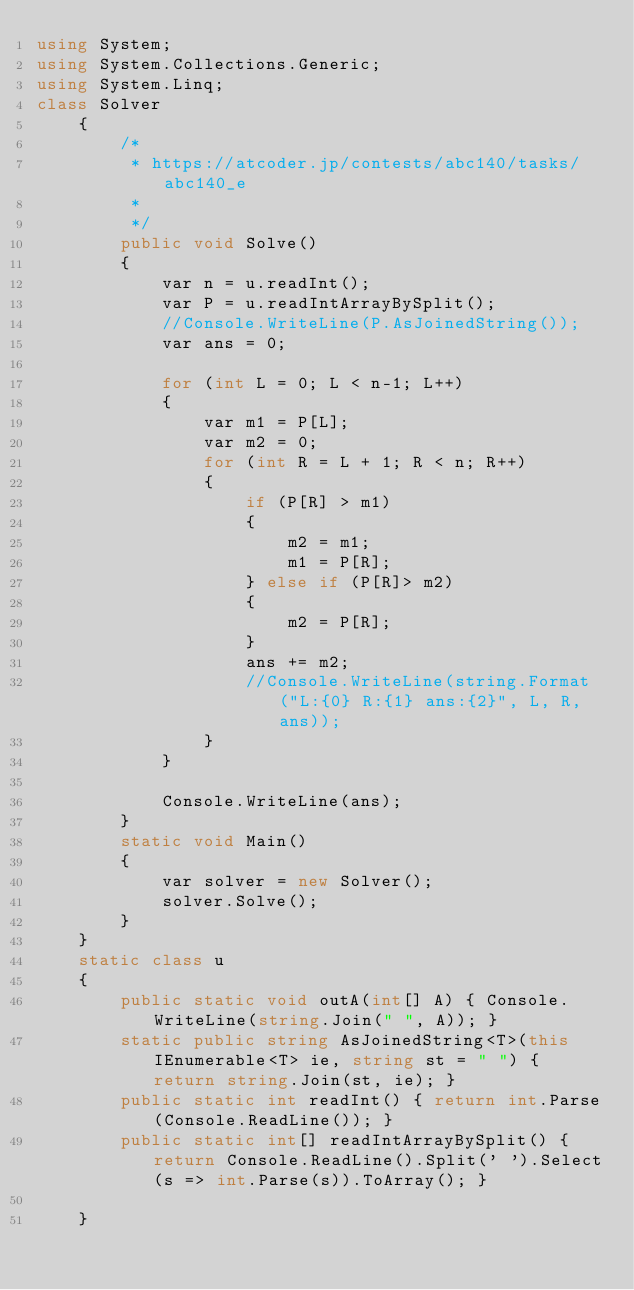Convert code to text. <code><loc_0><loc_0><loc_500><loc_500><_C#_>using System;
using System.Collections.Generic;
using System.Linq;
class Solver
    {
        /*
         * https://atcoder.jp/contests/abc140/tasks/abc140_e
         * 
         */
        public void Solve()
        {
            var n = u.readInt();
            var P = u.readIntArrayBySplit();
            //Console.WriteLine(P.AsJoinedString());
            var ans = 0;

            for (int L = 0; L < n-1; L++)
            {
                var m1 = P[L];
                var m2 = 0;
                for (int R = L + 1; R < n; R++)
                {
                    if (P[R] > m1)
                    {
                        m2 = m1;
                        m1 = P[R];
                    } else if (P[R]> m2)
                    {
                        m2 = P[R];
                    }
                    ans += m2;
                    //Console.WriteLine(string.Format("L:{0} R:{1} ans:{2}", L, R, ans));
                }
            }

            Console.WriteLine(ans);
        }
        static void Main()
        {
            var solver = new Solver();
            solver.Solve();
        }
    }
    static class u
    {
        public static void outA(int[] A) { Console.WriteLine(string.Join(" ", A)); }
        static public string AsJoinedString<T>(this IEnumerable<T> ie, string st = " ") { return string.Join(st, ie); }
        public static int readInt() { return int.Parse(Console.ReadLine()); }
        public static int[] readIntArrayBySplit() { return Console.ReadLine().Split(' ').Select(s => int.Parse(s)).ToArray(); }

    }</code> 